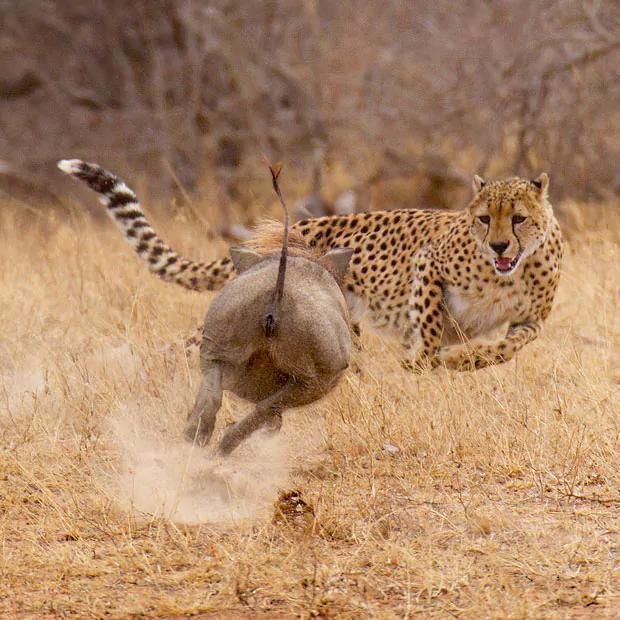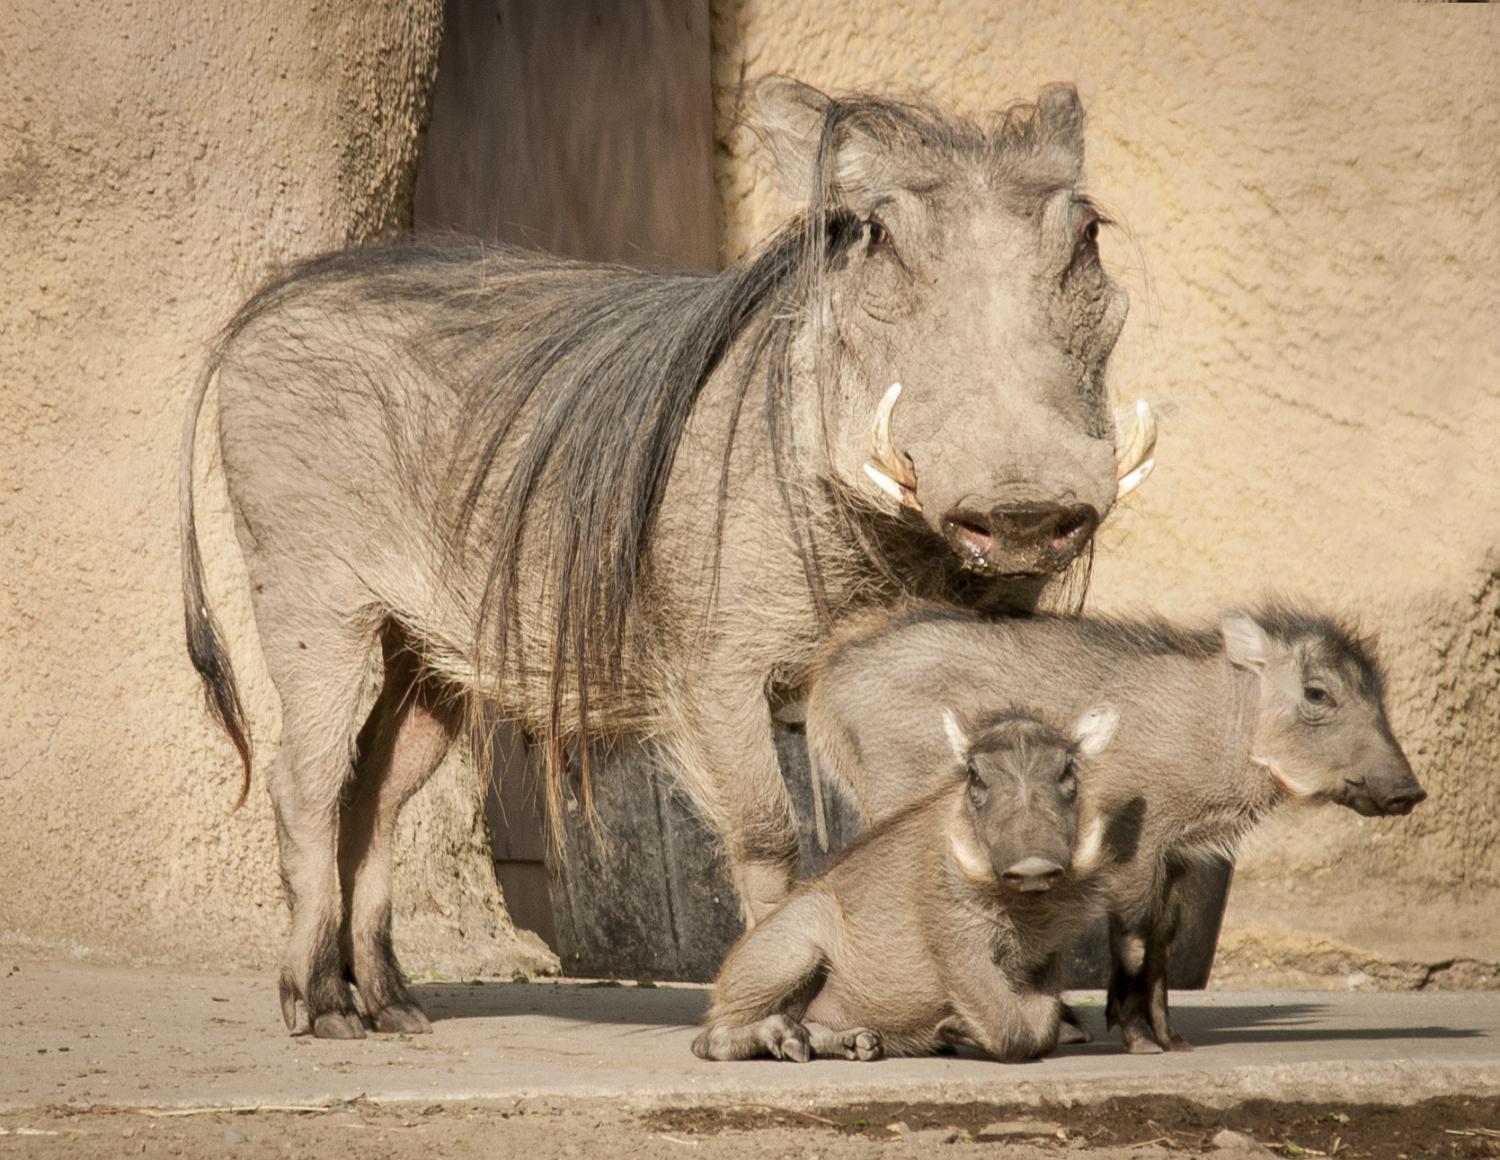The first image is the image on the left, the second image is the image on the right. Evaluate the accuracy of this statement regarding the images: "There are at least two piglets lying down.". Is it true? Answer yes or no. No. The first image is the image on the left, the second image is the image on the right. For the images shown, is this caption "Some baby pigs are cuddling near a wall." true? Answer yes or no. No. 